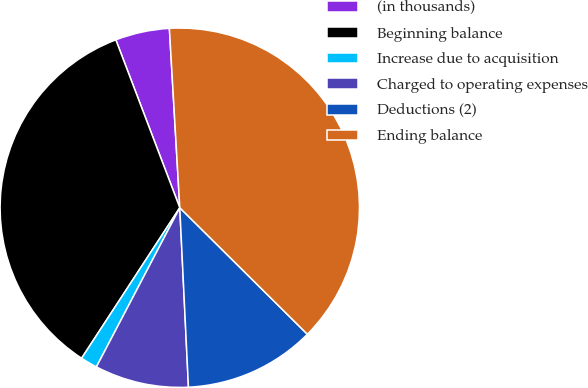<chart> <loc_0><loc_0><loc_500><loc_500><pie_chart><fcel>(in thousands)<fcel>Beginning balance<fcel>Increase due to acquisition<fcel>Charged to operating expenses<fcel>Deductions (2)<fcel>Ending balance<nl><fcel>4.87%<fcel>35.01%<fcel>1.52%<fcel>8.45%<fcel>11.8%<fcel>38.36%<nl></chart> 